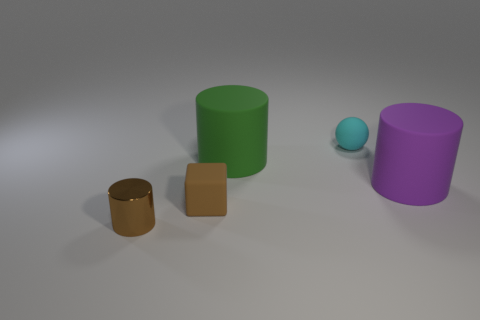Are there any other things that have the same material as the tiny brown cylinder?
Offer a terse response. No. What is the big cylinder that is on the right side of the tiny cyan matte thing made of?
Offer a terse response. Rubber. Are there any other things that are the same color as the metal cylinder?
Provide a short and direct response. Yes. The purple thing that is made of the same material as the green cylinder is what size?
Keep it short and to the point. Large. What number of small objects are either cylinders or blocks?
Provide a short and direct response. 2. There is a cylinder in front of the cylinder that is right of the large rubber cylinder that is to the left of the tiny cyan thing; how big is it?
Make the answer very short. Small. What number of purple rubber objects are the same size as the metal cylinder?
Ensure brevity in your answer.  0. How many objects are either small yellow metal things or rubber things to the left of the tiny rubber ball?
Ensure brevity in your answer.  2. The large green rubber thing is what shape?
Your answer should be very brief. Cylinder. Is the tiny shiny cylinder the same color as the tiny cube?
Offer a terse response. Yes. 